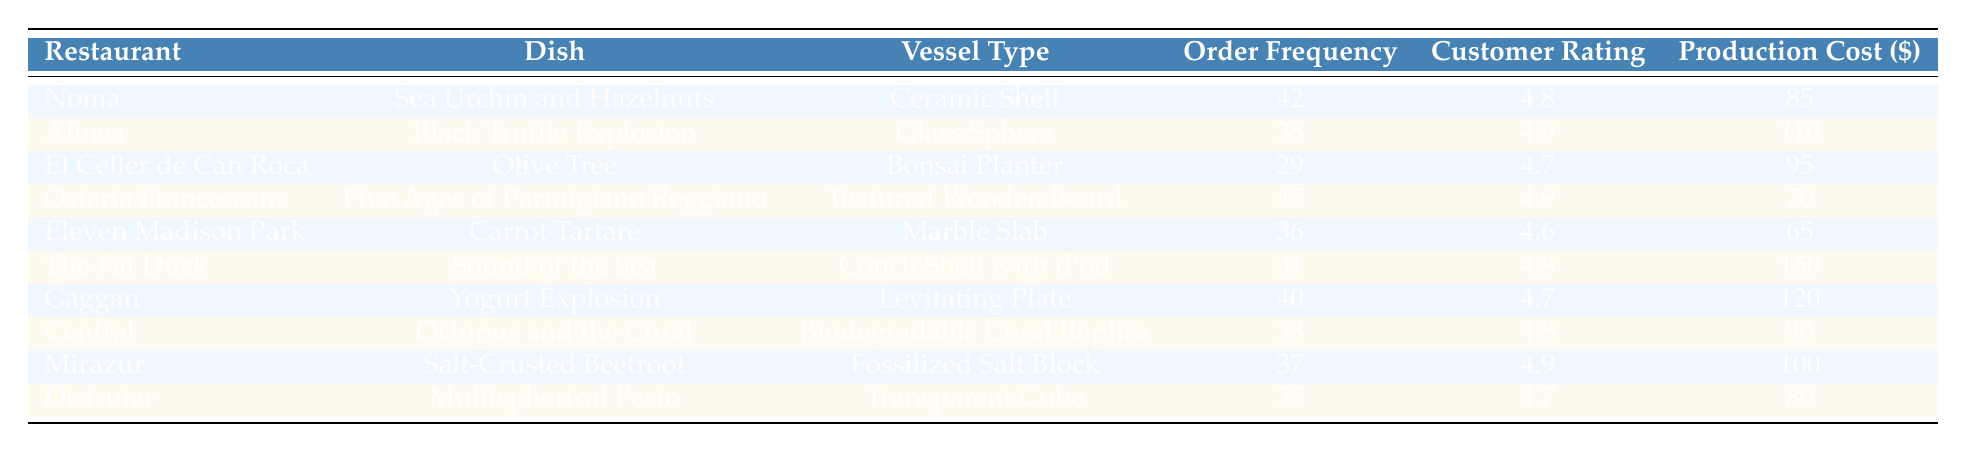What is the highest order frequency among the dishes? Looking at the "Order Frequency" column, the highest value is 45, which corresponds to the dish "Five Ages of Parmigiano Reggiano" from "Osteria Francescana".
Answer: 45 Which dish has the lowest customer rating? In the "Customer Rating" column, the lowest rating is 4.6, which corresponds to the dish "Carrot Tartare" from "Eleven Madison Park".
Answer: Carrot Tartare Is the production cost of the "Sound of the Sea" greater than 100 dollars? The "Production Cost" of the "Sound of the Sea" dish is 150 dollars, which is indeed greater than 100 dollars.
Answer: Yes What is the average production cost of the dishes served in "Noma" and "Osteria Francescana"? The production costs are 85 dollars for "Sea Urchin and Hazelnuts" (Noma) and 70 dollars for "Five Ages of Parmigiano Reggiano" (Osteria Francescana). The sum is 85 + 70 = 155. Divide by 2 to get the average: 155 / 2 = 77.5.
Answer: 77.5 How many dishes have a customer rating of 4.9 or higher? Checking the "Customer Rating" column, the dishes with ratings of 4.9 or higher are "Sea Urchin and Hazelnuts", "Black Truffle Explosion", "Five Ages of Parmigiano Reggiano", "Salt-Crusted Beetroot", and "Crispy Egg Yolk with Mushrooms" from the "Transparent Cube" dish. There are 5 dishes in total.
Answer: 5 Which dish has a production cost that is 20 dollars less than the "Yogurt Explosion"? The production cost of "Yogurt Explosion" is 120 dollars. 20 dollars less would be 100 dollars. The dish with a production cost of 100 dollars is "Salt-Crusted Beetroot", so this dish meets the criteria.
Answer: Salt-Crusted Beetroot Is there a dish with an order frequency of exactly 40? Checking the "Order Frequency" column, there is one dish, "Yogurt Explosion", with an order frequency of exactly 40.
Answer: Yes Which dish has the highest customer rating? The highest customer rating in the table is 4.9, which applies to "Black Truffle Explosion" and "Five Ages of Parmigiano Reggiano".
Answer: Black Truffle Explosion, Five Ages of Parmigiano Reggiano Which vessel type has the highest order frequency? The vessel type with the highest order frequency is "Textured Wooden Board", corresponding to an order frequency of 45 for the dish "Five Ages of Parmigiano Reggiano".
Answer: Textured Wooden Board 